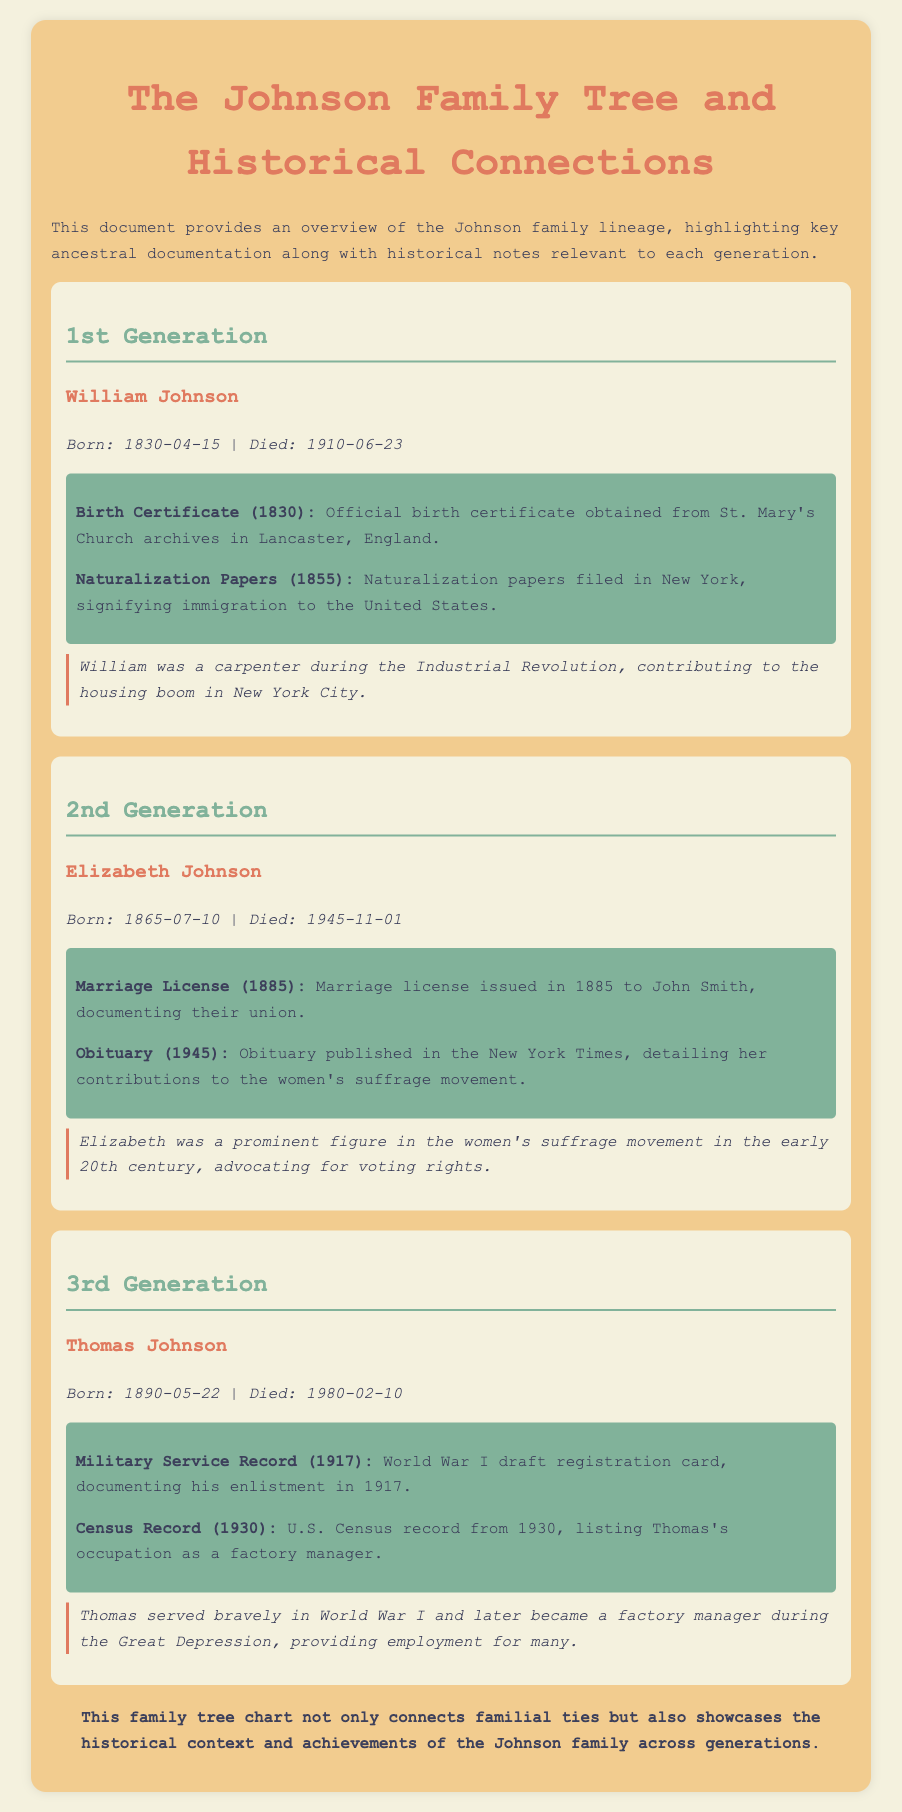What is the title of the document? The title is displayed at the top of the document and provides an overview of the contents.
Answer: The Johnson Family Tree and Historical Connections Who was born on April 15, 1830? The birth date indicates who the individual is in relation to the document's content.
Answer: William Johnson What significant movement was Elizabeth Johnson involved in? The document provides specific historical achievements attributed to Elizabeth Johnson.
Answer: Women's suffrage movement In what year did Thomas Johnson register for military service? This information highlights an important historical context relevant to the individual.
Answer: 1917 How many generations are included in the family tree? The document distinctly outlines different generations of the family lineage.
Answer: Three What type of document was provided for William Johnson's immigration? The document specifies the type of documentation associated with his move to another country.
Answer: Naturalization Papers What was Thomas Johnson's occupation according to the 1930 Census Record? The census record provides insights into Thomas's professional life.
Answer: Factory manager Which ancestor has a birth certificate documented in St. Mary's Church archives? This focuses on the documentation associated with the individuals in the family tree.
Answer: William Johnson 